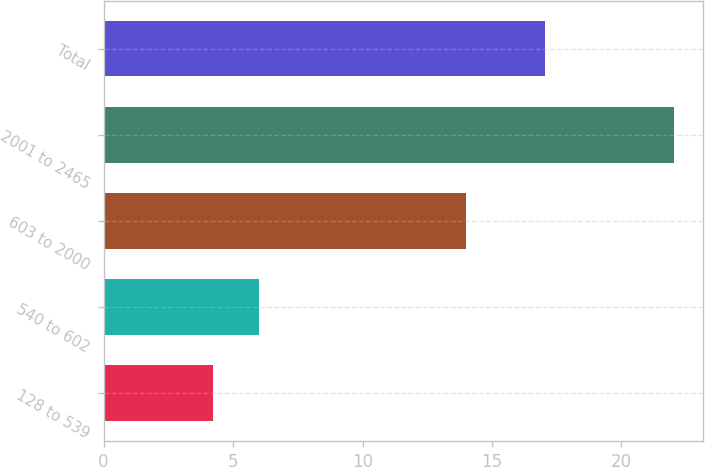Convert chart. <chart><loc_0><loc_0><loc_500><loc_500><bar_chart><fcel>128 to 539<fcel>540 to 602<fcel>603 to 2000<fcel>2001 to 2465<fcel>Total<nl><fcel>4.21<fcel>5.99<fcel>14.01<fcel>22.03<fcel>17.03<nl></chart> 